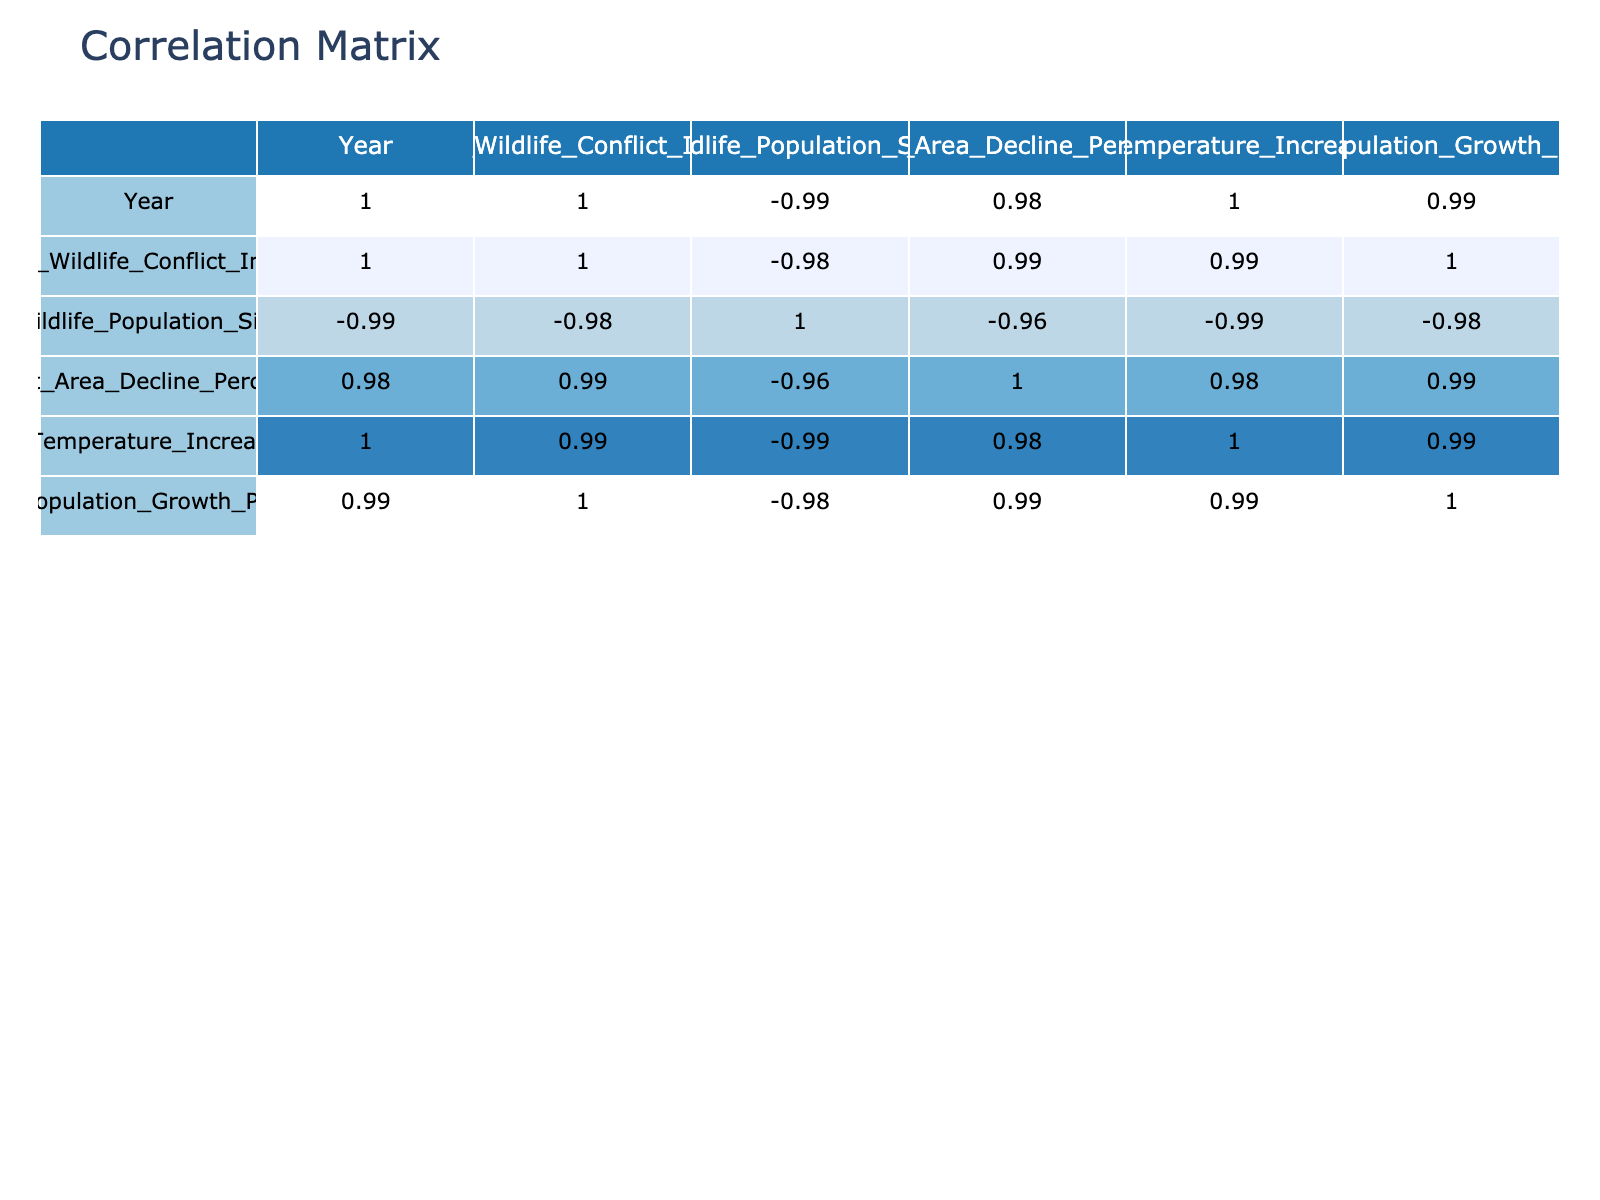What was the Human Wildlife Conflict Incidents count in 2021? From the table, at the row for the year 2021, the value in the column for Human Wildlife Conflict Incidents is 250.
Answer: 250 What is the correlation coefficient between Average Temperature Increase Celsius and Human Wildlife Conflict Incidents? The table shows a correlation coefficient between these two variables, which is approximately 0.94, indicating a strong positive correlation.
Answer: 0.94 What was the Wildlife Population Size in the year 2019? Looking at the row for 2019, the Wildlife Population Size is reported as 3800.
Answer: 3800 Is there a decline in habitat area percentage seen from 2015 to 2023? Comparing the values in the Habitat Area Decline Percentage column from 2015 (5%) to 2023 (15%), there is indeed a decline, as the percentage increased over the years.
Answer: Yes What is the average Human Population Growth Percentage over the years 2015 to 2023? To find the average, add the Human Population Growth Percentages from all years (2.1 + 2.5 + 2.8 + 3.0 + 3.2 + 3.5 + 3.8 + 4.0 + 4.5 = 21.6) and divide by 9 (the number of years), which gives 21.6/9 = 2.4.
Answer: 2.4 What was the year with the highest number of Human Wildlife Conflict Incidents? Scanning through the column for Human Wildlife Conflict Incidents reveals that 2023 has the highest count of 300 incidents.
Answer: 2023 What is the percentage increase in the Human Wildlife Conflict Incidents from 2015 to 2020? Calculate the difference between 2020 (220) and 2015 (120), which gives 220 - 120 = 100. Then divide by the original value (120) and multiply by 100 for percentage: (100/120) * 100 = 83.33%.
Answer: 83.33% Was there a year where the Average Temperature Increase Celsius did not rise compared to the previous year? By examining the values in the Average Temperature Increase column, it shows a contiguous rise from 0.5 in 2015 to 2.2 in 2023, with no year exhibiting a decrease.
Answer: No What is the total number of Human Wildlife Conflict Incidents recorded from 2015 to 2023? Summing the incidents from each year (120 + 150 + 160 + 180 + 200 + 220 + 250 + 270 + 300 = 1850) provides the total incidents over this span.
Answer: 1850 What was the overall trend in the Wildlife Population Size over the years? Observing the Wildlife Population Size column shows a consistent decline from 4500 in 2015 down to 3300 in 2023, indicating an overall decreasing trend.
Answer: Decreasing 